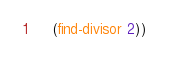<code> <loc_0><loc_0><loc_500><loc_500><_Scheme_>
    (find-divisor 2))

</code> 